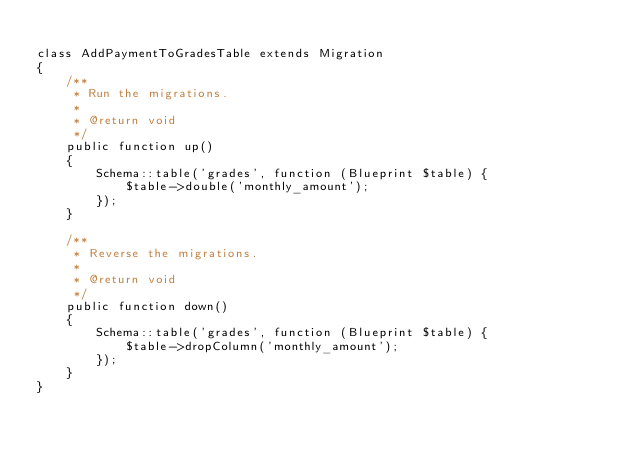<code> <loc_0><loc_0><loc_500><loc_500><_PHP_>
class AddPaymentToGradesTable extends Migration
{
    /**
     * Run the migrations.
     *
     * @return void
     */
    public function up()
    {
        Schema::table('grades', function (Blueprint $table) {
            $table->double('monthly_amount');
        });
    }

    /**
     * Reverse the migrations.
     *
     * @return void
     */
    public function down()
    {
        Schema::table('grades', function (Blueprint $table) {
            $table->dropColumn('monthly_amount');
        });
    }
}
</code> 